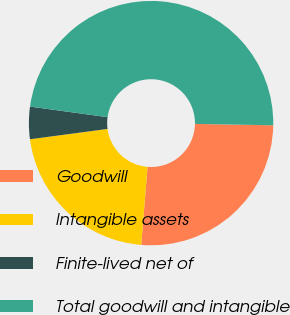<chart> <loc_0><loc_0><loc_500><loc_500><pie_chart><fcel>Goodwill<fcel>Intangible assets<fcel>Finite-lived net of<fcel>Total goodwill and intangible<nl><fcel>26.0%<fcel>21.61%<fcel>4.27%<fcel>48.12%<nl></chart> 